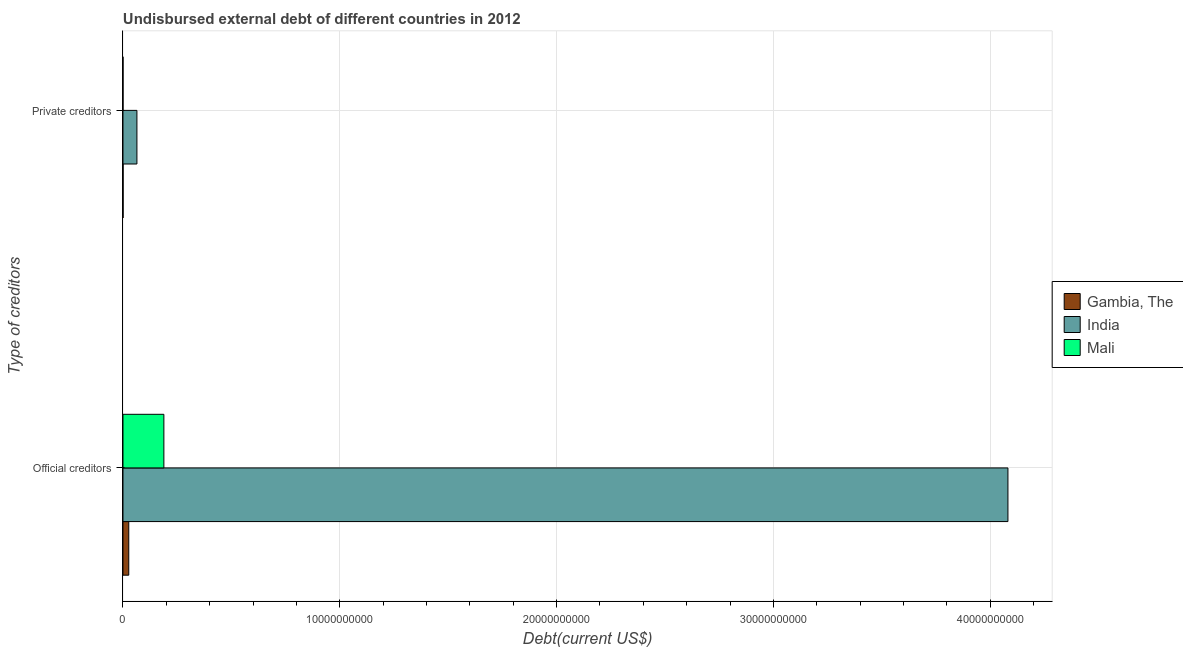What is the label of the 2nd group of bars from the top?
Your response must be concise. Official creditors. What is the undisbursed external debt of private creditors in Mali?
Give a very brief answer. 7.72e+05. Across all countries, what is the maximum undisbursed external debt of private creditors?
Your answer should be very brief. 6.43e+08. Across all countries, what is the minimum undisbursed external debt of official creditors?
Your answer should be very brief. 2.67e+08. In which country was the undisbursed external debt of private creditors maximum?
Provide a succinct answer. India. In which country was the undisbursed external debt of official creditors minimum?
Provide a succinct answer. Gambia, The. What is the total undisbursed external debt of private creditors in the graph?
Provide a short and direct response. 6.48e+08. What is the difference between the undisbursed external debt of official creditors in Mali and that in Gambia, The?
Ensure brevity in your answer.  1.62e+09. What is the difference between the undisbursed external debt of official creditors in Mali and the undisbursed external debt of private creditors in India?
Give a very brief answer. 1.24e+09. What is the average undisbursed external debt of private creditors per country?
Give a very brief answer. 2.16e+08. What is the difference between the undisbursed external debt of private creditors and undisbursed external debt of official creditors in India?
Ensure brevity in your answer.  -4.02e+1. What is the ratio of the undisbursed external debt of official creditors in Mali to that in Gambia, The?
Your answer should be very brief. 7.07. Is the undisbursed external debt of private creditors in Gambia, The less than that in Mali?
Ensure brevity in your answer.  No. In how many countries, is the undisbursed external debt of official creditors greater than the average undisbursed external debt of official creditors taken over all countries?
Give a very brief answer. 1. What does the 2nd bar from the top in Private creditors represents?
Your answer should be compact. India. How many bars are there?
Your response must be concise. 6. How many countries are there in the graph?
Your answer should be very brief. 3. What is the difference between two consecutive major ticks on the X-axis?
Provide a short and direct response. 1.00e+1. How are the legend labels stacked?
Give a very brief answer. Vertical. What is the title of the graph?
Provide a succinct answer. Undisbursed external debt of different countries in 2012. Does "American Samoa" appear as one of the legend labels in the graph?
Make the answer very short. No. What is the label or title of the X-axis?
Give a very brief answer. Debt(current US$). What is the label or title of the Y-axis?
Give a very brief answer. Type of creditors. What is the Debt(current US$) of Gambia, The in Official creditors?
Keep it short and to the point. 2.67e+08. What is the Debt(current US$) in India in Official creditors?
Your response must be concise. 4.08e+1. What is the Debt(current US$) of Mali in Official creditors?
Ensure brevity in your answer.  1.89e+09. What is the Debt(current US$) of Gambia, The in Private creditors?
Offer a very short reply. 4.34e+06. What is the Debt(current US$) in India in Private creditors?
Ensure brevity in your answer.  6.43e+08. What is the Debt(current US$) in Mali in Private creditors?
Make the answer very short. 7.72e+05. Across all Type of creditors, what is the maximum Debt(current US$) of Gambia, The?
Offer a very short reply. 2.67e+08. Across all Type of creditors, what is the maximum Debt(current US$) in India?
Offer a terse response. 4.08e+1. Across all Type of creditors, what is the maximum Debt(current US$) in Mali?
Keep it short and to the point. 1.89e+09. Across all Type of creditors, what is the minimum Debt(current US$) of Gambia, The?
Ensure brevity in your answer.  4.34e+06. Across all Type of creditors, what is the minimum Debt(current US$) of India?
Make the answer very short. 6.43e+08. Across all Type of creditors, what is the minimum Debt(current US$) in Mali?
Your answer should be very brief. 7.72e+05. What is the total Debt(current US$) of Gambia, The in the graph?
Provide a short and direct response. 2.71e+08. What is the total Debt(current US$) in India in the graph?
Make the answer very short. 4.15e+1. What is the total Debt(current US$) of Mali in the graph?
Provide a short and direct response. 1.89e+09. What is the difference between the Debt(current US$) in Gambia, The in Official creditors and that in Private creditors?
Make the answer very short. 2.62e+08. What is the difference between the Debt(current US$) in India in Official creditors and that in Private creditors?
Provide a short and direct response. 4.02e+1. What is the difference between the Debt(current US$) of Mali in Official creditors and that in Private creditors?
Offer a very short reply. 1.89e+09. What is the difference between the Debt(current US$) in Gambia, The in Official creditors and the Debt(current US$) in India in Private creditors?
Provide a short and direct response. -3.76e+08. What is the difference between the Debt(current US$) in Gambia, The in Official creditors and the Debt(current US$) in Mali in Private creditors?
Your answer should be compact. 2.66e+08. What is the difference between the Debt(current US$) in India in Official creditors and the Debt(current US$) in Mali in Private creditors?
Offer a terse response. 4.08e+1. What is the average Debt(current US$) of Gambia, The per Type of creditors?
Your answer should be very brief. 1.36e+08. What is the average Debt(current US$) of India per Type of creditors?
Give a very brief answer. 2.07e+1. What is the average Debt(current US$) in Mali per Type of creditors?
Provide a succinct answer. 9.43e+08. What is the difference between the Debt(current US$) in Gambia, The and Debt(current US$) in India in Official creditors?
Your answer should be very brief. -4.06e+1. What is the difference between the Debt(current US$) in Gambia, The and Debt(current US$) in Mali in Official creditors?
Give a very brief answer. -1.62e+09. What is the difference between the Debt(current US$) in India and Debt(current US$) in Mali in Official creditors?
Provide a short and direct response. 3.89e+1. What is the difference between the Debt(current US$) of Gambia, The and Debt(current US$) of India in Private creditors?
Make the answer very short. -6.39e+08. What is the difference between the Debt(current US$) of Gambia, The and Debt(current US$) of Mali in Private creditors?
Ensure brevity in your answer.  3.57e+06. What is the difference between the Debt(current US$) of India and Debt(current US$) of Mali in Private creditors?
Offer a terse response. 6.42e+08. What is the ratio of the Debt(current US$) in Gambia, The in Official creditors to that in Private creditors?
Provide a short and direct response. 61.49. What is the ratio of the Debt(current US$) of India in Official creditors to that in Private creditors?
Provide a short and direct response. 63.46. What is the ratio of the Debt(current US$) of Mali in Official creditors to that in Private creditors?
Your answer should be compact. 2443.28. What is the difference between the highest and the second highest Debt(current US$) of Gambia, The?
Give a very brief answer. 2.62e+08. What is the difference between the highest and the second highest Debt(current US$) in India?
Your answer should be compact. 4.02e+1. What is the difference between the highest and the second highest Debt(current US$) in Mali?
Your response must be concise. 1.89e+09. What is the difference between the highest and the lowest Debt(current US$) in Gambia, The?
Offer a terse response. 2.62e+08. What is the difference between the highest and the lowest Debt(current US$) of India?
Keep it short and to the point. 4.02e+1. What is the difference between the highest and the lowest Debt(current US$) in Mali?
Offer a terse response. 1.89e+09. 